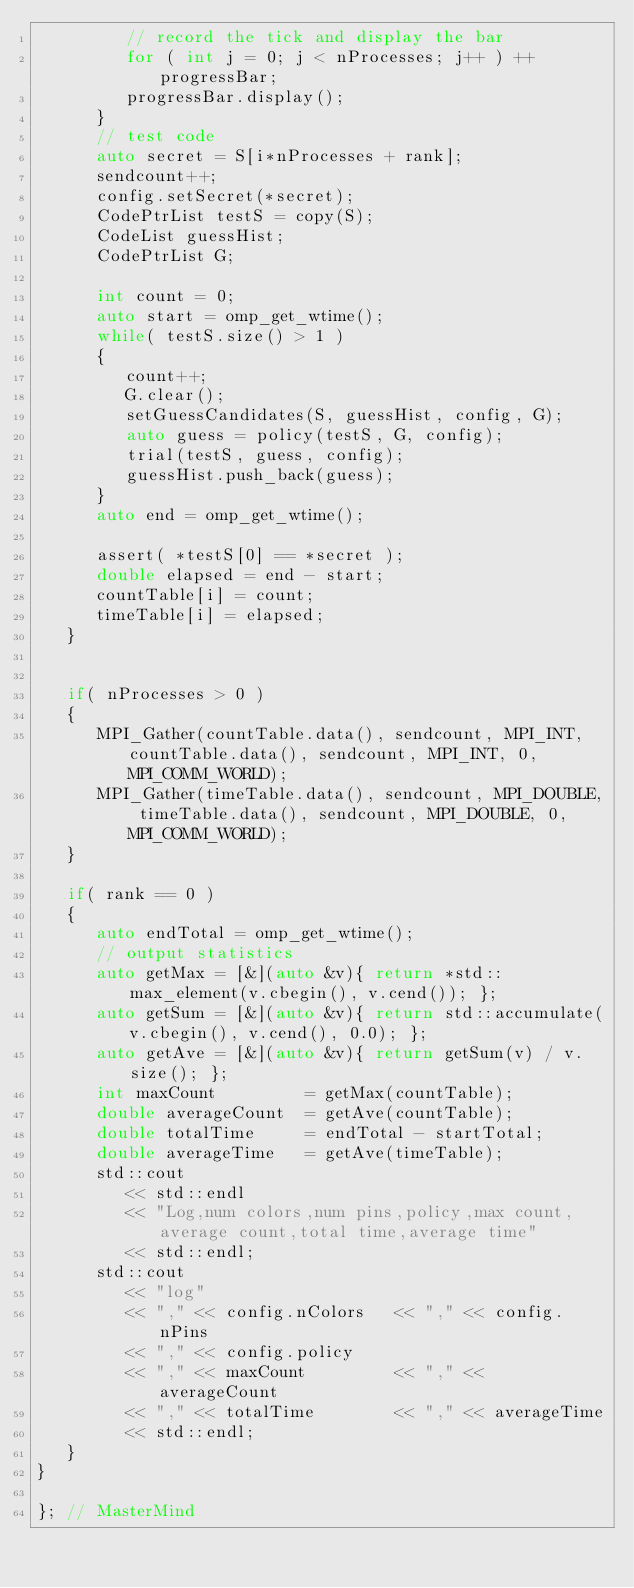Convert code to text. <code><loc_0><loc_0><loc_500><loc_500><_C++_>         // record the tick and display the bar
         for ( int j = 0; j < nProcesses; j++ ) ++progressBar;
         progressBar.display();
      }
      // test code
      auto secret = S[i*nProcesses + rank];
      sendcount++;
      config.setSecret(*secret);
      CodePtrList testS = copy(S);
      CodeList guessHist;
      CodePtrList G;

      int count = 0;
      auto start = omp_get_wtime();
      while( testS.size() > 1 )
      {
         count++;
         G.clear();
         setGuessCandidates(S, guessHist, config, G);
         auto guess = policy(testS, G, config);
         trial(testS, guess, config);
         guessHist.push_back(guess);
      }
      auto end = omp_get_wtime();

      assert( *testS[0] == *secret );
      double elapsed = end - start;
      countTable[i] = count;
      timeTable[i] = elapsed;
   }


   if( nProcesses > 0 )
   {
      MPI_Gather(countTable.data(), sendcount, MPI_INT, countTable.data(), sendcount, MPI_INT, 0, MPI_COMM_WORLD);
      MPI_Gather(timeTable.data(), sendcount, MPI_DOUBLE, timeTable.data(), sendcount, MPI_DOUBLE, 0, MPI_COMM_WORLD);
   }

   if( rank == 0 )
   {
      auto endTotal = omp_get_wtime();
      // output statistics
      auto getMax = [&](auto &v){ return *std::max_element(v.cbegin(), v.cend()); };
      auto getSum = [&](auto &v){ return std::accumulate(v.cbegin(), v.cend(), 0.0); };
      auto getAve = [&](auto &v){ return getSum(v) / v.size(); };
      int maxCount         = getMax(countTable);
      double averageCount  = getAve(countTable);
      double totalTime     = endTotal - startTotal;
      double averageTime   = getAve(timeTable);
      std::cout
         << std::endl
         << "Log,num colors,num pins,policy,max count,average count,total time,average time"
         << std::endl;
      std::cout
         << "log"
         << "," << config.nColors   << "," << config.nPins
         << "," << config.policy
         << "," << maxCount         << "," << averageCount
         << "," << totalTime        << "," << averageTime
         << std::endl;
   }
}

}; // MasterMind

</code> 